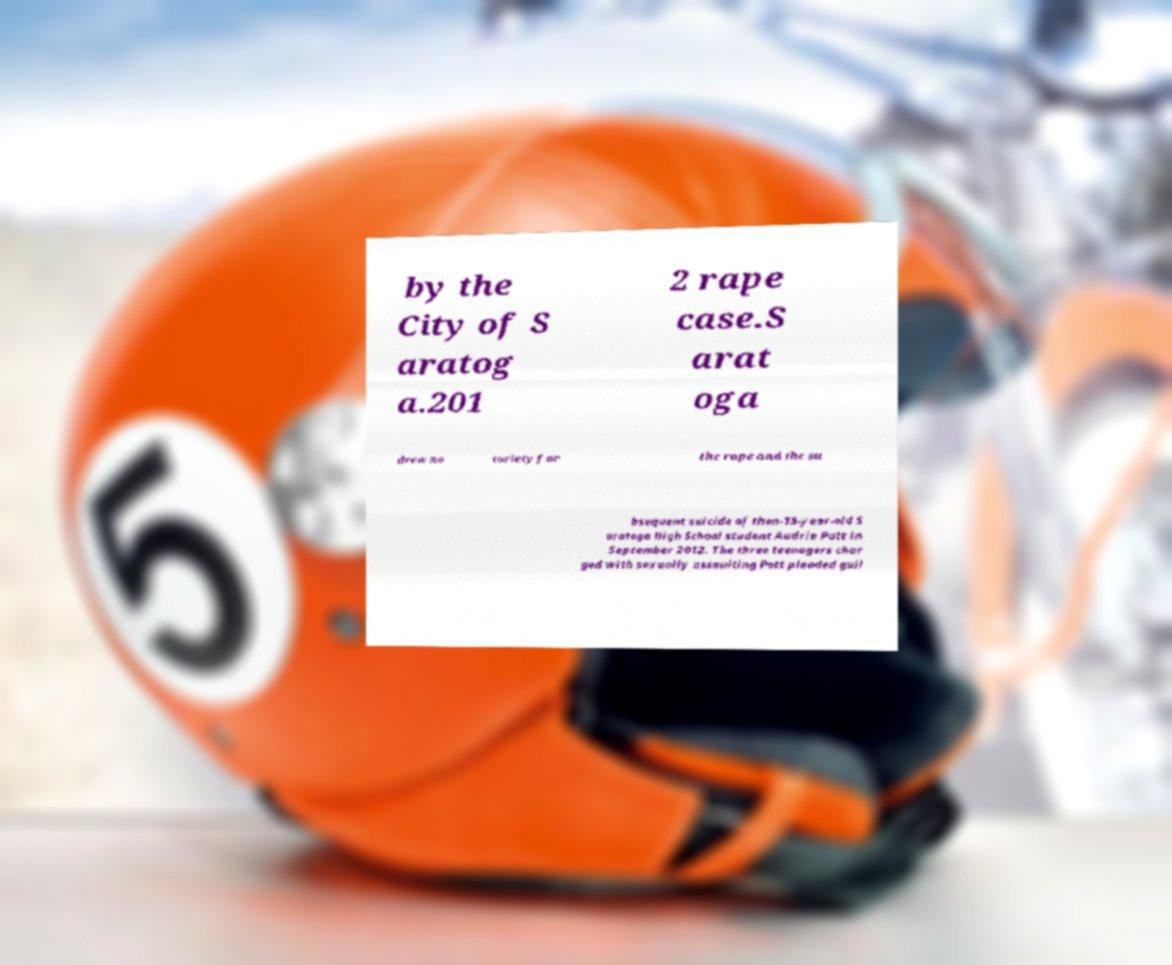What messages or text are displayed in this image? I need them in a readable, typed format. by the City of S aratog a.201 2 rape case.S arat oga drew no toriety for the rape and the su bsequent suicide of then-15-year-old S aratoga High School student Audrie Pott in September 2012. The three teenagers char ged with sexually assaulting Pott pleaded guil 